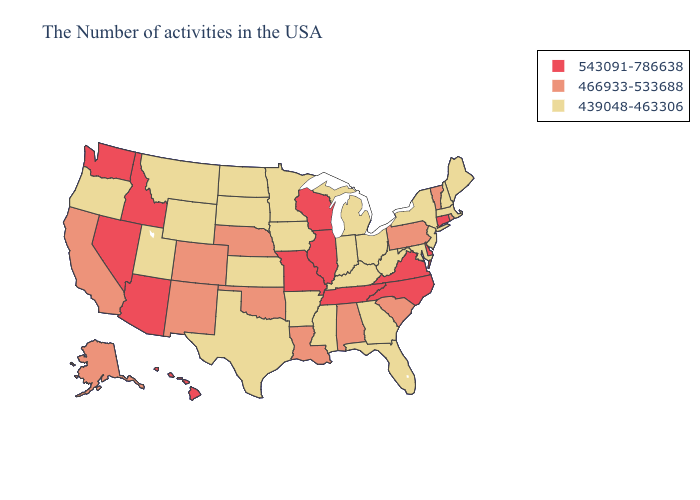Name the states that have a value in the range 543091-786638?
Keep it brief. Connecticut, Delaware, Virginia, North Carolina, Tennessee, Wisconsin, Illinois, Missouri, Arizona, Idaho, Nevada, Washington, Hawaii. Name the states that have a value in the range 439048-463306?
Give a very brief answer. Maine, Massachusetts, New Hampshire, New York, New Jersey, Maryland, West Virginia, Ohio, Florida, Georgia, Michigan, Kentucky, Indiana, Mississippi, Arkansas, Minnesota, Iowa, Kansas, Texas, South Dakota, North Dakota, Wyoming, Utah, Montana, Oregon. Does Connecticut have the lowest value in the USA?
Keep it brief. No. What is the highest value in the USA?
Keep it brief. 543091-786638. What is the lowest value in the West?
Give a very brief answer. 439048-463306. What is the lowest value in the MidWest?
Quick response, please. 439048-463306. What is the value of Delaware?
Short answer required. 543091-786638. What is the highest value in the USA?
Write a very short answer. 543091-786638. What is the value of Nebraska?
Quick response, please. 466933-533688. Among the states that border Iowa , does Illinois have the highest value?
Keep it brief. Yes. Does Connecticut have the highest value in the Northeast?
Keep it brief. Yes. Does California have a lower value than Kansas?
Short answer required. No. Name the states that have a value in the range 543091-786638?
Keep it brief. Connecticut, Delaware, Virginia, North Carolina, Tennessee, Wisconsin, Illinois, Missouri, Arizona, Idaho, Nevada, Washington, Hawaii. What is the value of Hawaii?
Be succinct. 543091-786638. Which states have the highest value in the USA?
Short answer required. Connecticut, Delaware, Virginia, North Carolina, Tennessee, Wisconsin, Illinois, Missouri, Arizona, Idaho, Nevada, Washington, Hawaii. 